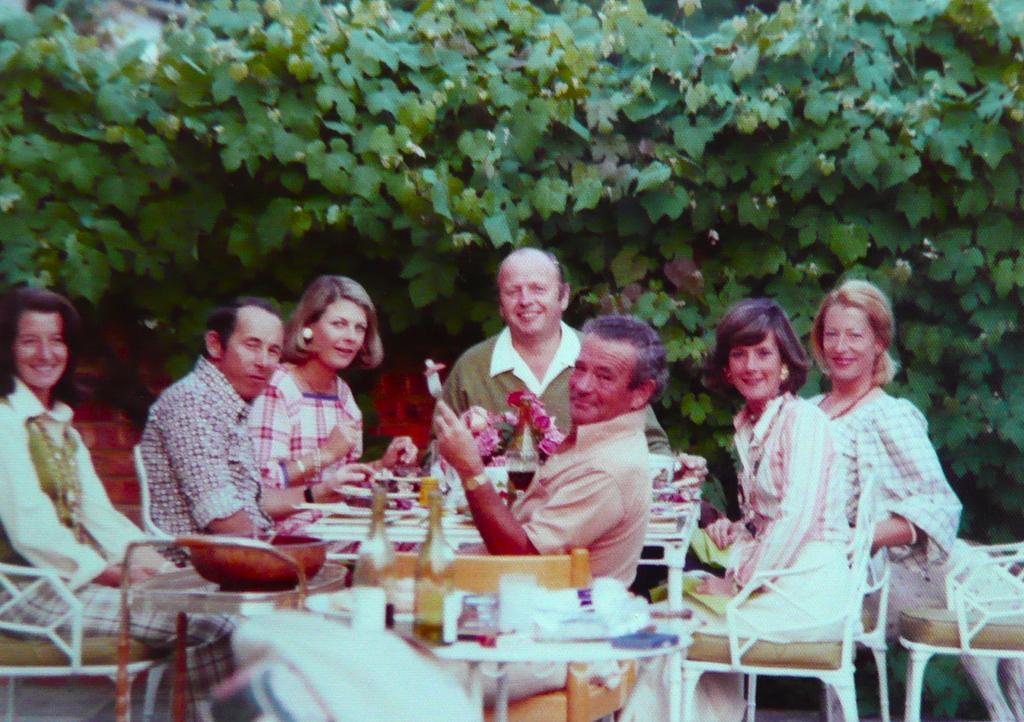Can you describe this image briefly? On the background we can see tree. here we can see all the persons sitting on chairs in front of a table and giving a still to the camera and all are smiling. On the table we can use bottles, vessel, glass and few things. 